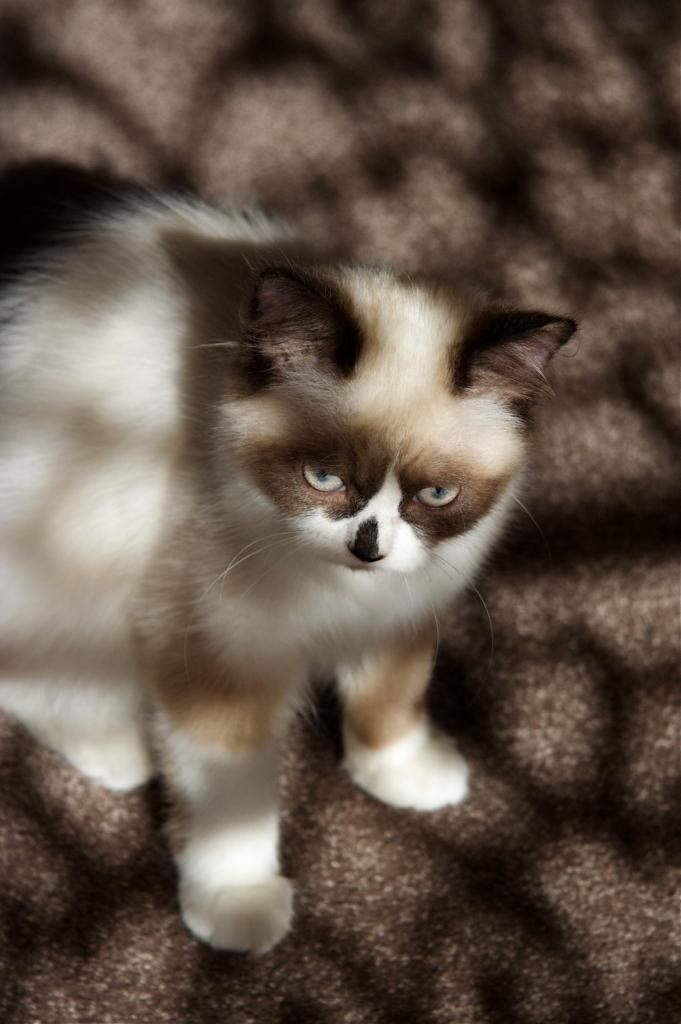What type of animal is in the image? There is a cat in the image. Where is the cat located in the image? The cat is sitting on the ground. What type of hearing aid is the cat wearing in the image? There is no hearing aid visible on the cat in the image. How many snails can be seen interacting with the cat in the image? There are no snails present in the image. 